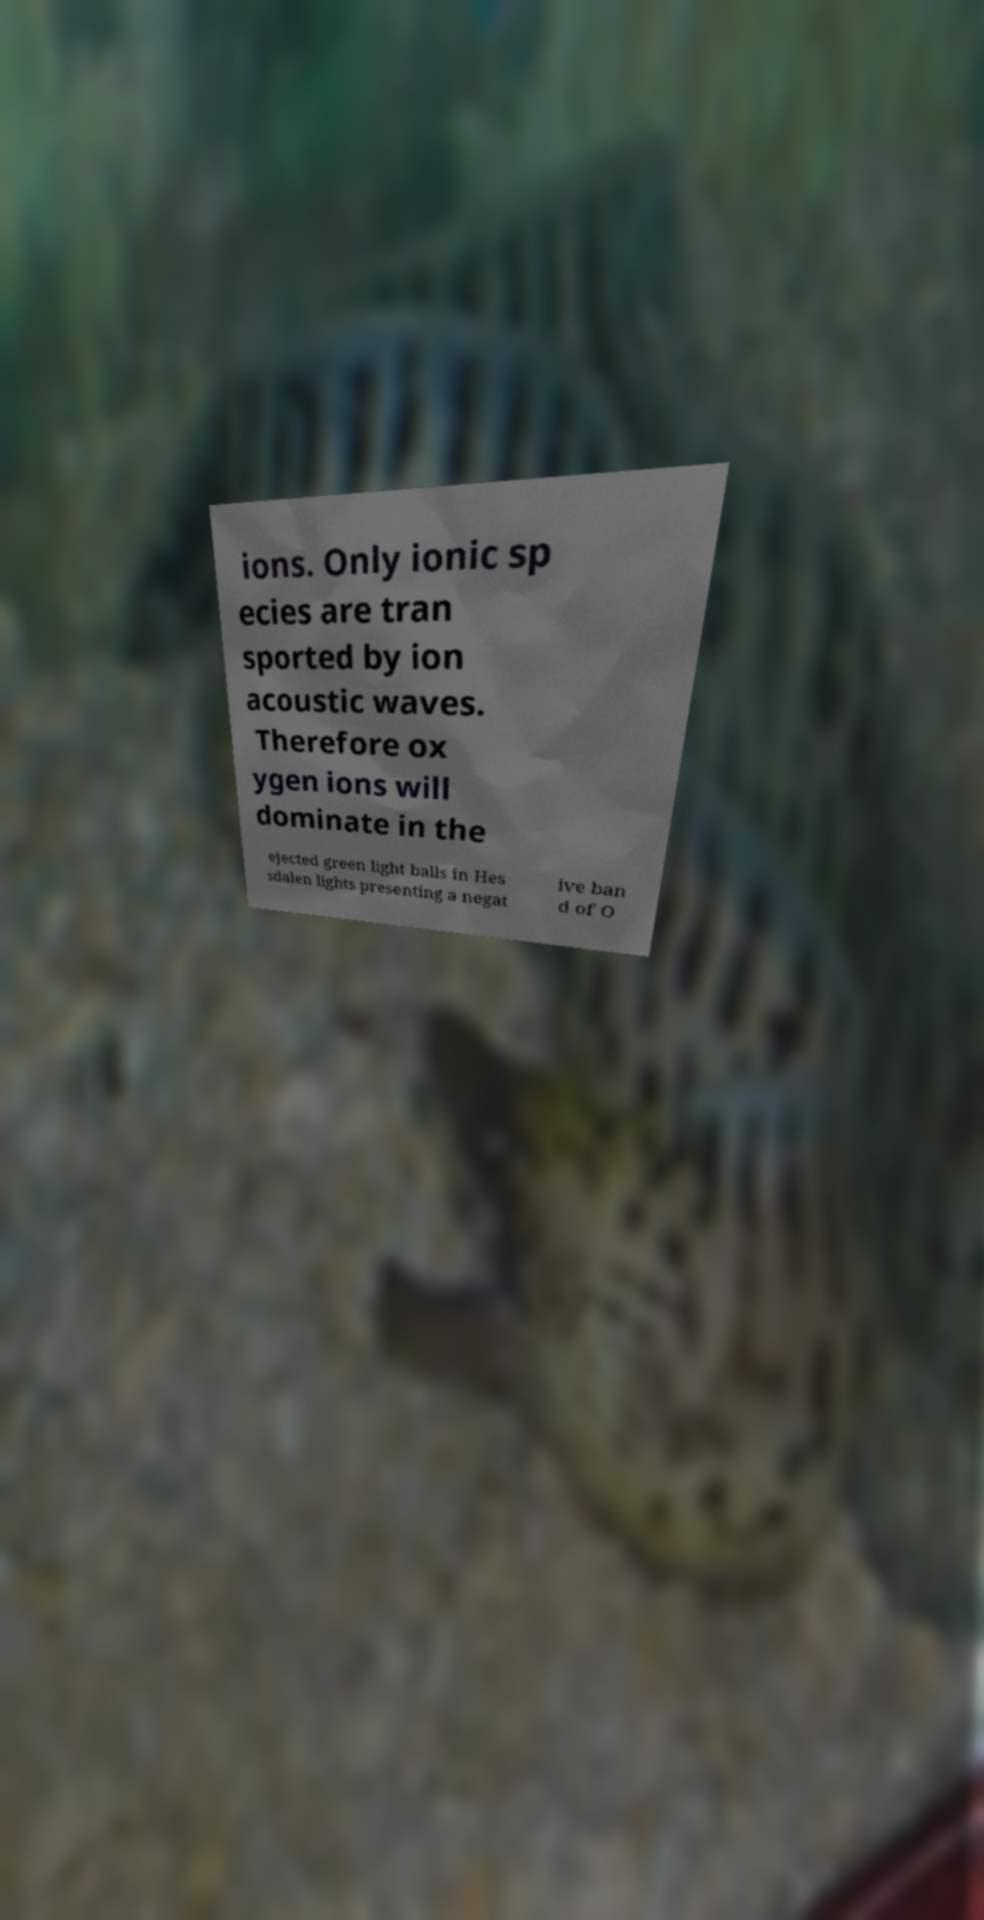What messages or text are displayed in this image? I need them in a readable, typed format. ions. Only ionic sp ecies are tran sported by ion acoustic waves. Therefore ox ygen ions will dominate in the ejected green light balls in Hes sdalen lights presenting a negat ive ban d of O 